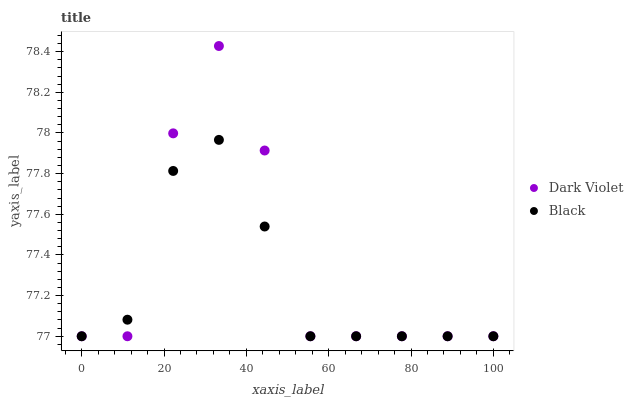Does Black have the minimum area under the curve?
Answer yes or no. Yes. Does Dark Violet have the maximum area under the curve?
Answer yes or no. Yes. Does Dark Violet have the minimum area under the curve?
Answer yes or no. No. Is Black the smoothest?
Answer yes or no. Yes. Is Dark Violet the roughest?
Answer yes or no. Yes. Is Dark Violet the smoothest?
Answer yes or no. No. Does Black have the lowest value?
Answer yes or no. Yes. Does Dark Violet have the highest value?
Answer yes or no. Yes. Does Black intersect Dark Violet?
Answer yes or no. Yes. Is Black less than Dark Violet?
Answer yes or no. No. Is Black greater than Dark Violet?
Answer yes or no. No. 